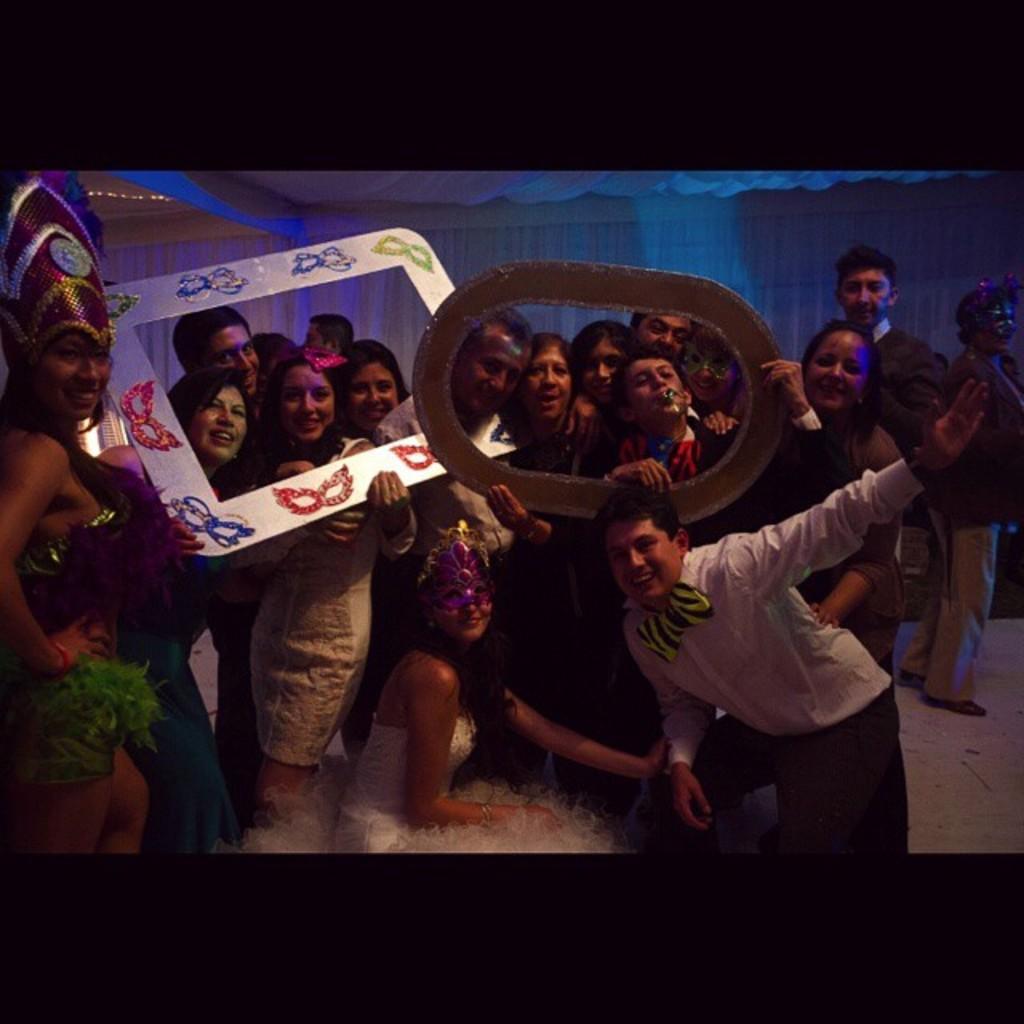Please provide a concise description of this image. This picture seems to be clicked inside the hall. In the center we can see the group of people posing for a photograph. On the left corner we can see a woman wearing a costume, standing and smiling. In the background we can see the curtains, decoration lights and we can see some other items. 